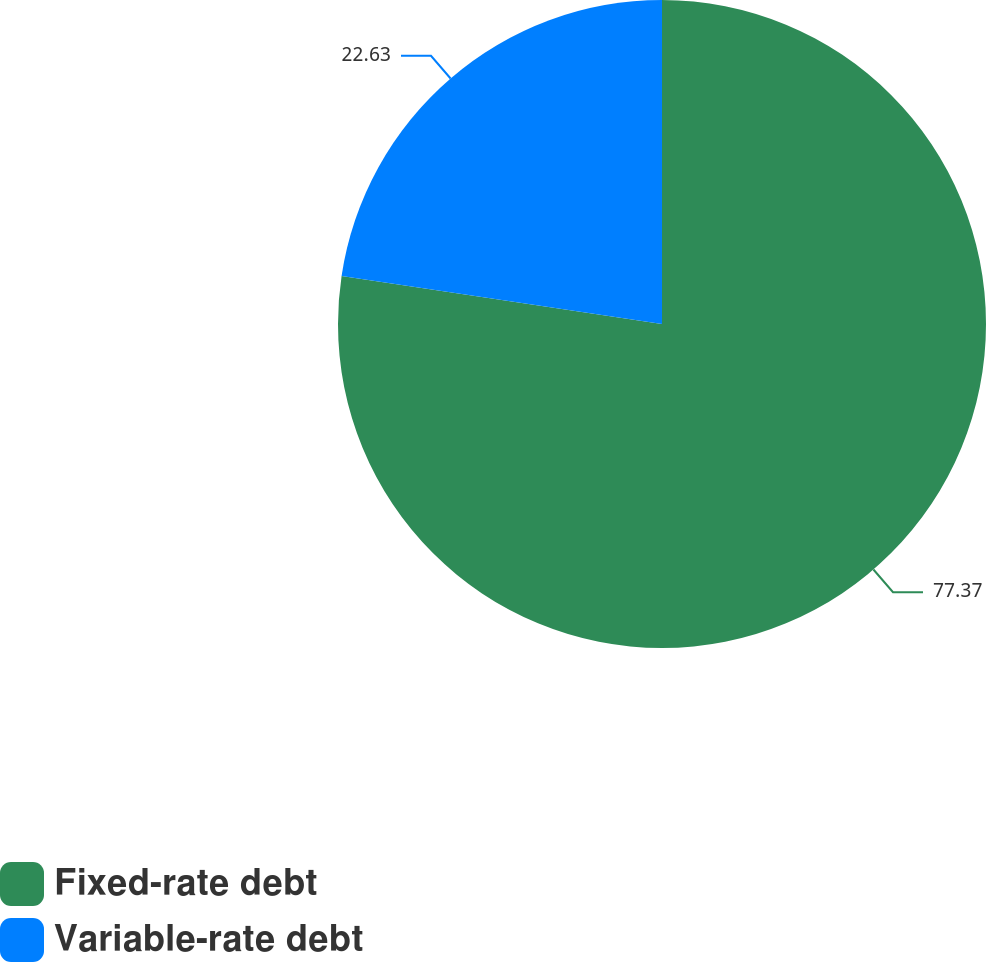<chart> <loc_0><loc_0><loc_500><loc_500><pie_chart><fcel>Fixed-rate debt<fcel>Variable-rate debt<nl><fcel>77.37%<fcel>22.63%<nl></chart> 